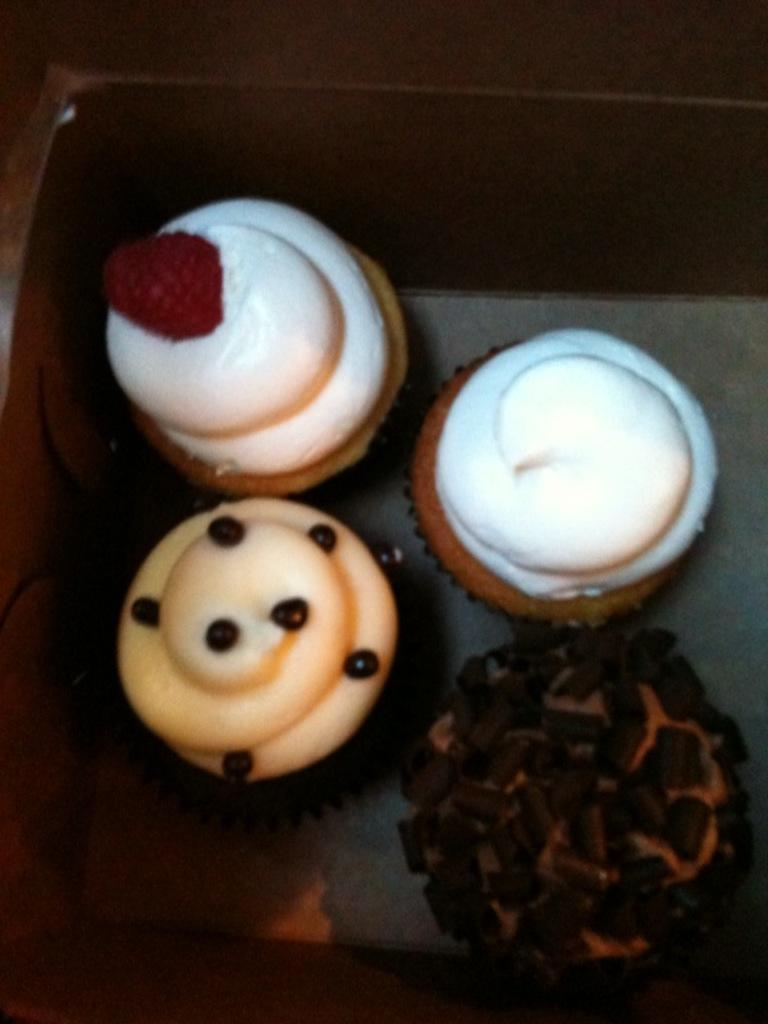How many cupcakes are visible in the image? There are four cupcakes in the image. What is on top of the cupcakes? The cupcakes have cream on them. What type of volleyball is being used to lift the cupcakes in the image? There is no volleyball present in the image, and the cupcakes are not being lifted. 